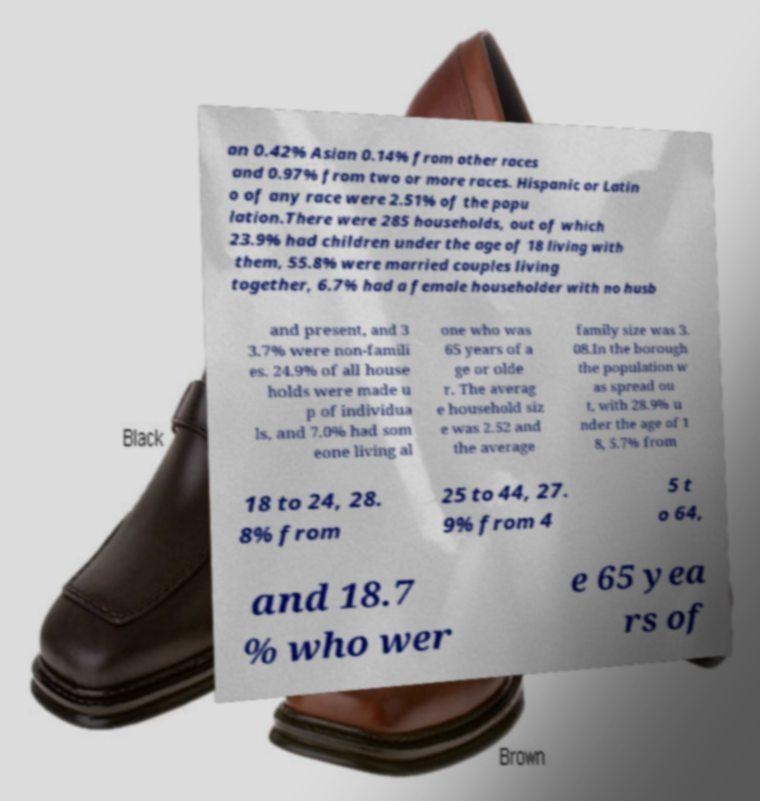Could you assist in decoding the text presented in this image and type it out clearly? an 0.42% Asian 0.14% from other races and 0.97% from two or more races. Hispanic or Latin o of any race were 2.51% of the popu lation.There were 285 households, out of which 23.9% had children under the age of 18 living with them, 55.8% were married couples living together, 6.7% had a female householder with no husb and present, and 3 3.7% were non-famili es. 24.9% of all house holds were made u p of individua ls, and 7.0% had som eone living al one who was 65 years of a ge or olde r. The averag e household siz e was 2.52 and the average family size was 3. 08.In the borough the population w as spread ou t, with 28.9% u nder the age of 1 8, 5.7% from 18 to 24, 28. 8% from 25 to 44, 27. 9% from 4 5 t o 64, and 18.7 % who wer e 65 yea rs of 